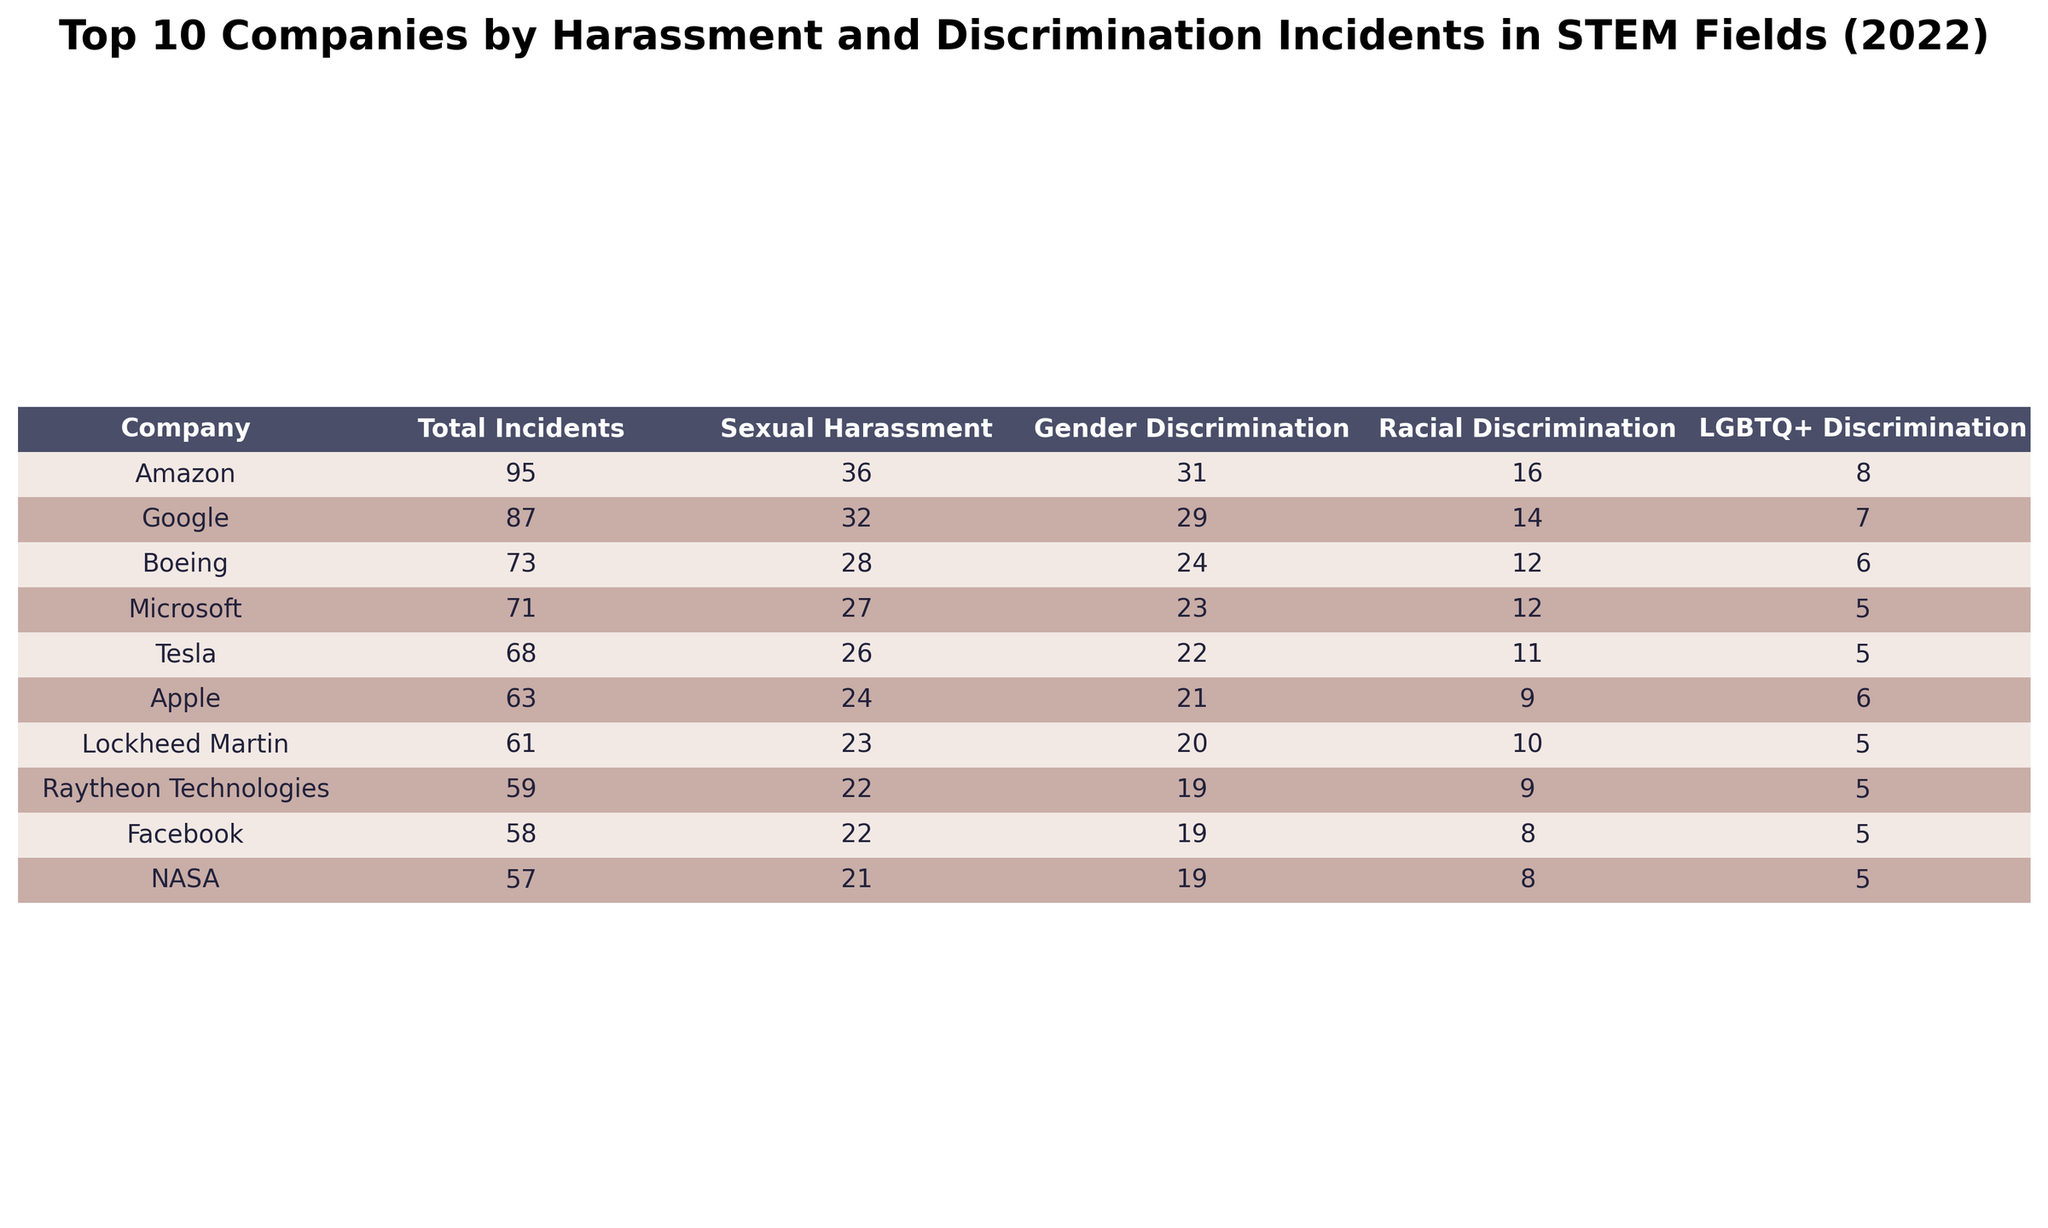What company reported the highest number of sexual harassment incidents? By examining the "Sexual Harassment" column, we can see that Amazon has the highest value at 36 incidents.
Answer: Amazon How many total incidents were reported by Google and Apple combined? We find the total incidents for Google (87) and Apple (63) and sum them: 87 + 63 = 150.
Answer: 150 Is it true that more incidents of racial discrimination were reported than LGBTQ+ discrimination by Facebook? Facebook reports 8 incidents of racial discrimination and 5 incidents of LGBTQ+ discrimination, making it true that racial discrimination incidents are higher.
Answer: Yes Which company resolved the highest number of harassment cases? Looking at the "Resolved Cases" column, Amazon resolved 67 cases, which is the highest compared to the other companies.
Answer: Amazon What is the total number of cases of gender discrimination across the top three companies? We sum the gender discrimination cases for the top three companies: Amazon (31) + Google (29) + Microsoft (23) = 83 total cases.
Answer: 83 Which company had the most ongoing investigations, and how many were there? By checking the "Ongoing Investigations" column, Amazon has the highest count with 28 ongoing investigations.
Answer: Amazon, 28 What is the average number of total incidents reported by the listed companies? We sum the total incidents: (87 + 63 + 71 + 95 + 58 + 52 + 49 + 41 + 38 + 46 + 55 + 43 + 35 + 39 + 68 + 57 + 73 + 61 + 54 + 59) = 1061 incidents, and there are 20 companies, so the average is 1061 / 20 = 53.05.
Answer: 53.05 How many companies reported fewer than 50 total incidents? By examining the "Total Incidents" column, we count the companies with values less than 50: Nvidia (41), Adobe (38), Intel (49). This gives us a total of 3 companies.
Answer: 3 What is the difference in the number of sexual harassment incidents between Boeing and Tesla? We subtract Boeing’s sexual harassment incidents (28) from Tesla’s (26): 28 - 26 = 2. Hence, Boeing reported 2 more incidents.
Answer: 2 Which incident type had the least number of cases reported by IBM? Looking at the columns, IBM reported 7 cases of racial discrimination, which is the least compared to other incident types reported: sexual harassment (19), gender discrimination (17), LGBTQ+ discrimination (4).
Answer: Racial Discrimination 